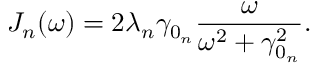Convert formula to latex. <formula><loc_0><loc_0><loc_500><loc_500>J _ { n } ( \omega ) = 2 \lambda _ { n } \gamma _ { 0 _ { n } } \frac { \omega } { \omega ^ { 2 } + \gamma _ { 0 _ { n } } ^ { 2 } } .</formula> 